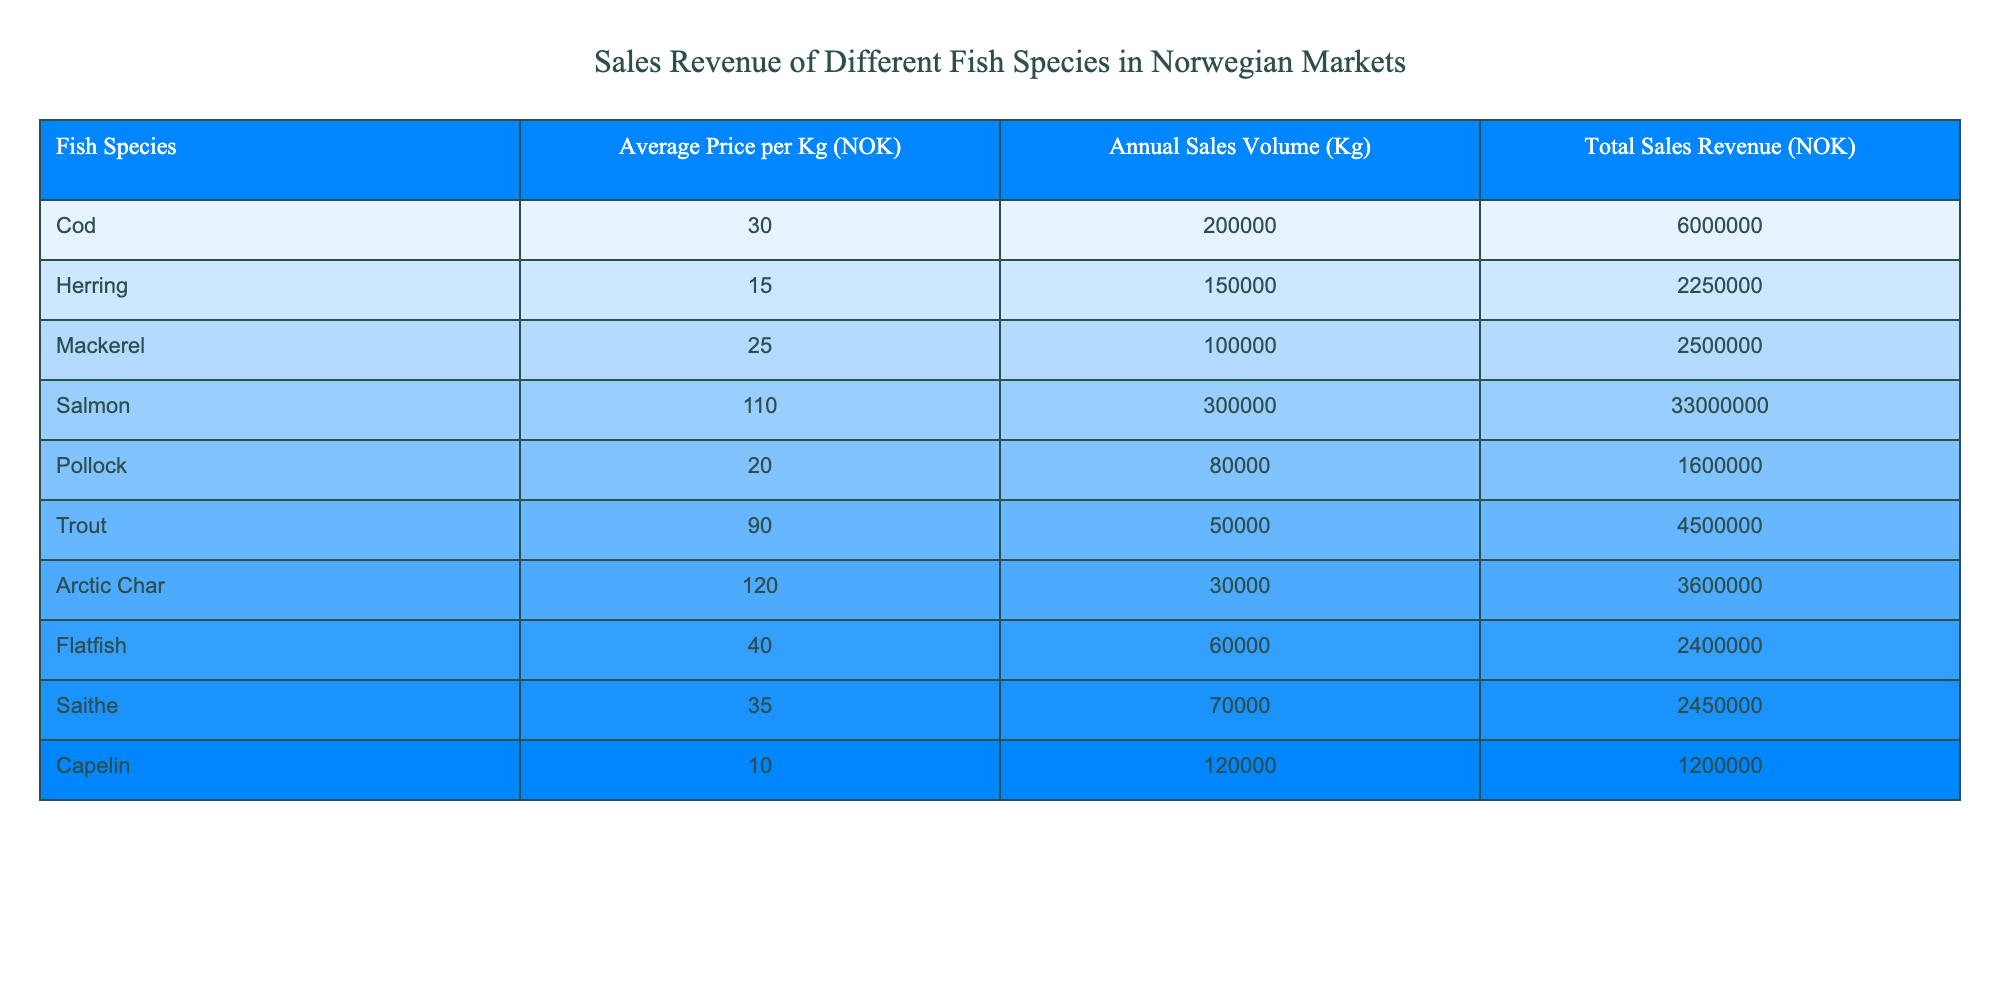What is the total sales revenue for Salmon? The table shows the total sales revenue column for each fish species. For Salmon, the total sales revenue is listed as 33,000,000 NOK.
Answer: 33,000,000 NOK Which fish species has the highest average price per kilogram? By inspecting the average price per kilogram column, Arctic Char has the highest price listed at 120 NOK.
Answer: Arctic Char What is the combined total sales revenue for Cod and Mackerel? Looking at the total sales revenue, Cod has 6,000,000 NOK and Mackerel has 2,500,000 NOK. The sum is 6,000,000 + 2,500,000 = 8,500,000 NOK.
Answer: 8,500,000 NOK Is the total sales revenue for Herring greater than that for Pollock? Herring's total sales revenue is listed as 2,250,000 NOK, while Pollock's is 1,600,000 NOK. Since 2,250,000 is greater than 1,600,000, the answer is yes.
Answer: Yes What is the average total sales revenue for the fish species listed in the table? First, sum the total sales revenues for all species: 6,000,000 + 2,250,000 + 2,500,000 + 33,000,000 + 1,600,000 + 4,500,000 + 3,600,000 + 2,400,000 + 2,450,000 + 1,200,000 = 56,750,000 NOK. There are 10 species, so the average is 56,750,000 / 10 = 5,675,000 NOK.
Answer: 5,675,000 NOK Which fish species has a total sales revenue less than 2,500,000 NOK? By reviewing the total sales revenue for each species, Pollock (1,600,000 NOK) and Capelin (1,200,000 NOK) are below 2,500,000 NOK.
Answer: Pollock and Capelin What is the sales volume of Trout? From the sales volume column, Trout is listed with a volume of 50,000 Kg.
Answer: 50,000 Kg 